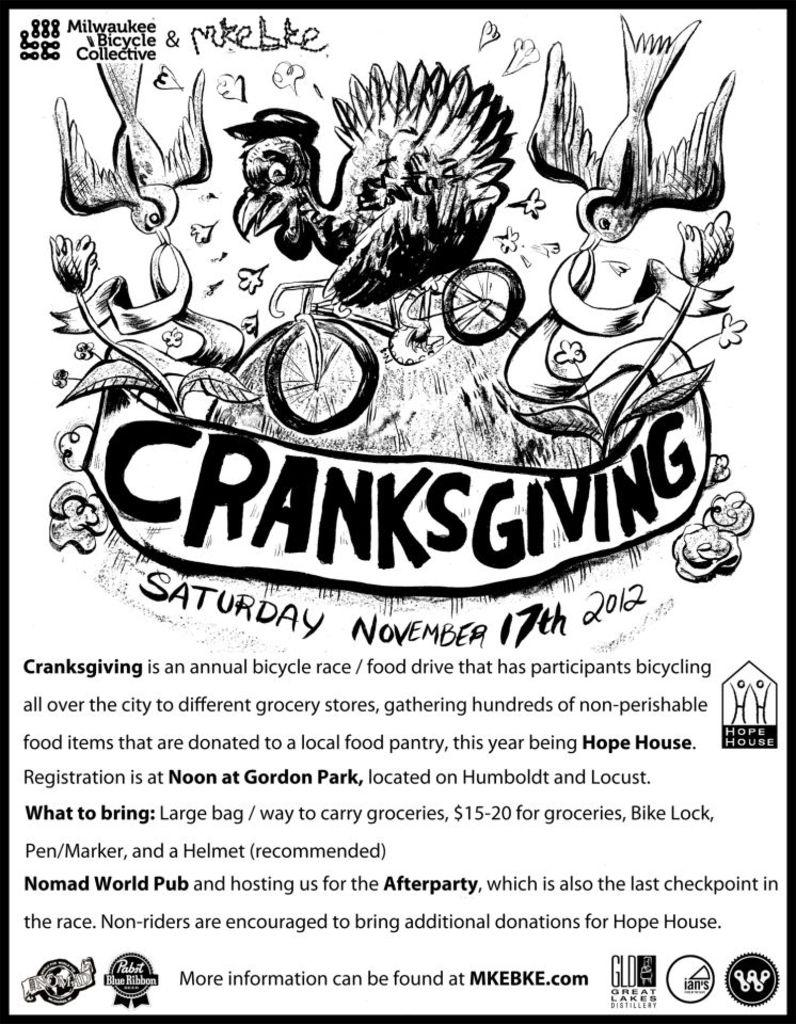<image>
Describe the image concisely. A black and white flyer advertises a bicycle race called Cranksgiving. 